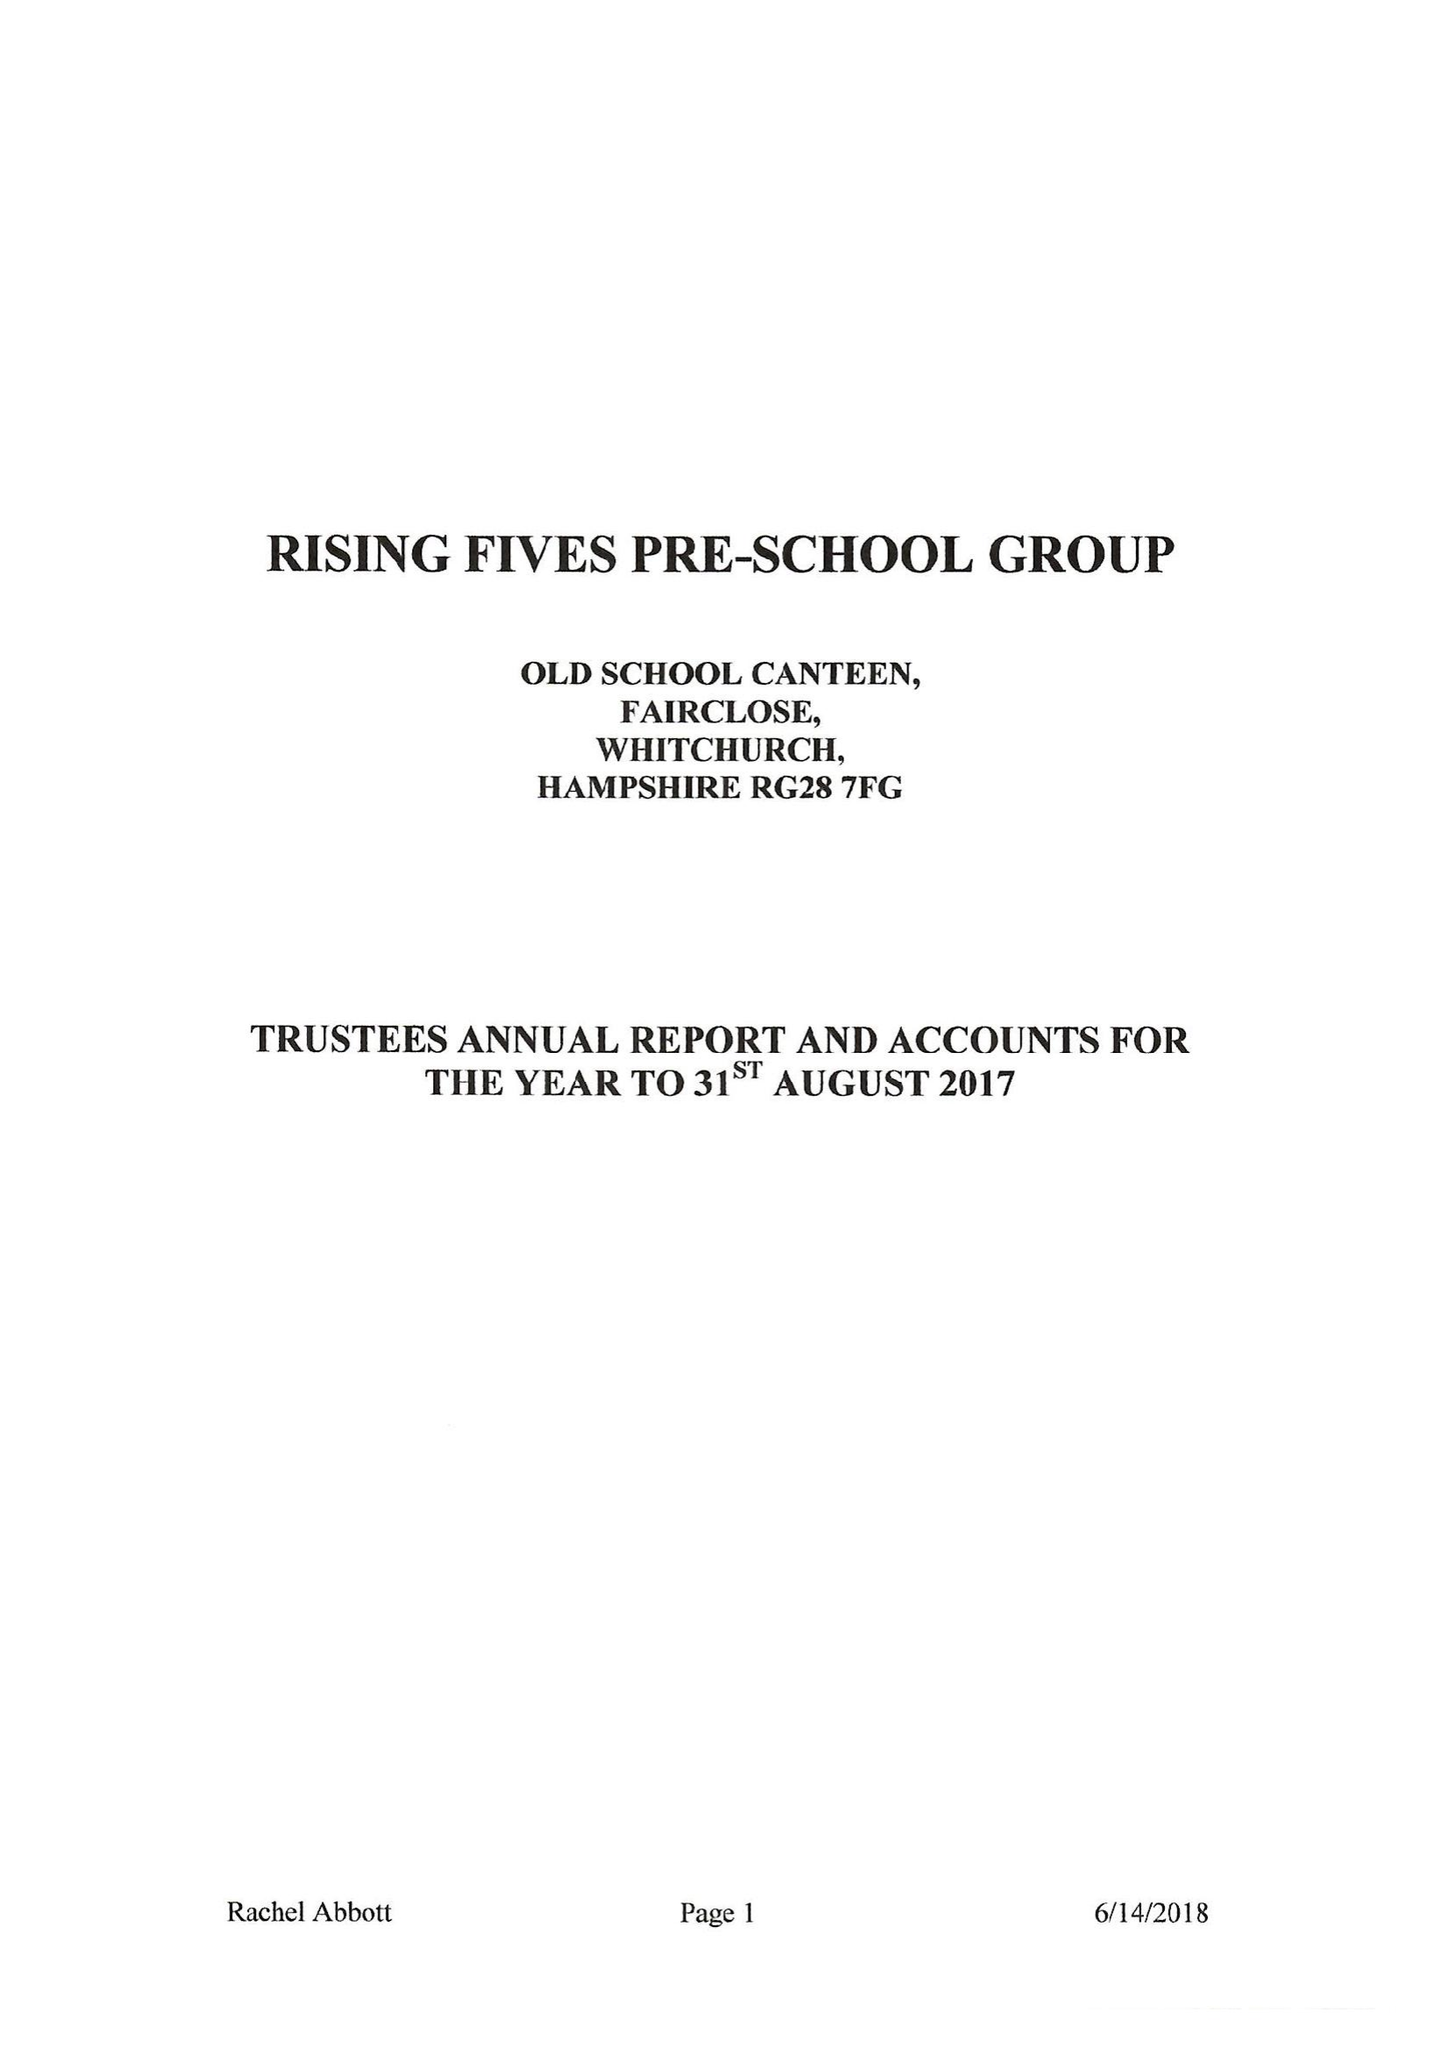What is the value for the report_date?
Answer the question using a single word or phrase. 2017-08-31 